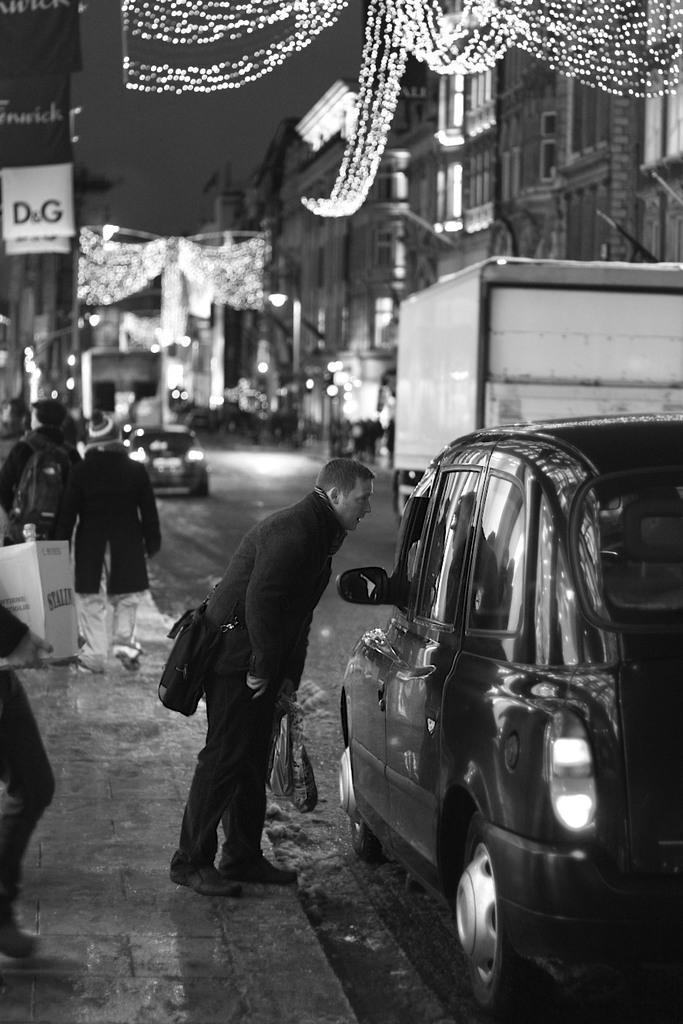Please provide a concise description of this image. This is a black and white picture. I can see vehicles on the road, there are group of people standing, there are buildings and lights. 